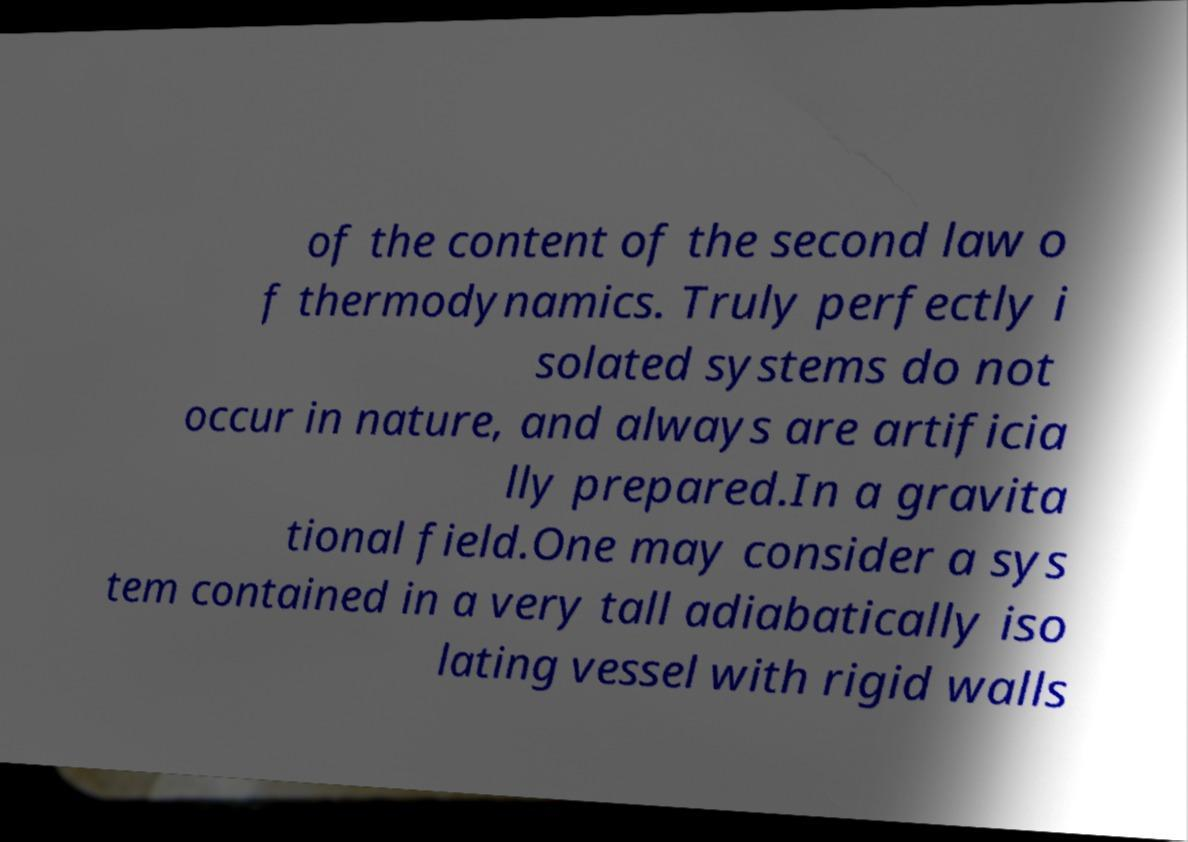For documentation purposes, I need the text within this image transcribed. Could you provide that? of the content of the second law o f thermodynamics. Truly perfectly i solated systems do not occur in nature, and always are artificia lly prepared.In a gravita tional field.One may consider a sys tem contained in a very tall adiabatically iso lating vessel with rigid walls 